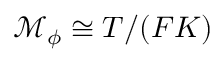<formula> <loc_0><loc_0><loc_500><loc_500>\mathcal { M } _ { \phi } \cong T / ( F K )</formula> 